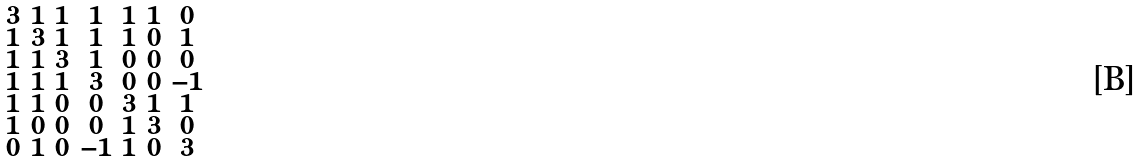Convert formula to latex. <formula><loc_0><loc_0><loc_500><loc_500>\begin{smallmatrix} 3 & 1 & 1 & 1 & 1 & 1 & 0 \\ 1 & 3 & 1 & 1 & 1 & 0 & 1 \\ 1 & 1 & 3 & 1 & 0 & 0 & 0 \\ 1 & 1 & 1 & 3 & 0 & 0 & - 1 \\ 1 & 1 & 0 & 0 & 3 & 1 & 1 \\ 1 & 0 & 0 & 0 & 1 & 3 & 0 \\ 0 & 1 & 0 & - 1 & 1 & 0 & 3 \end{smallmatrix}</formula> 